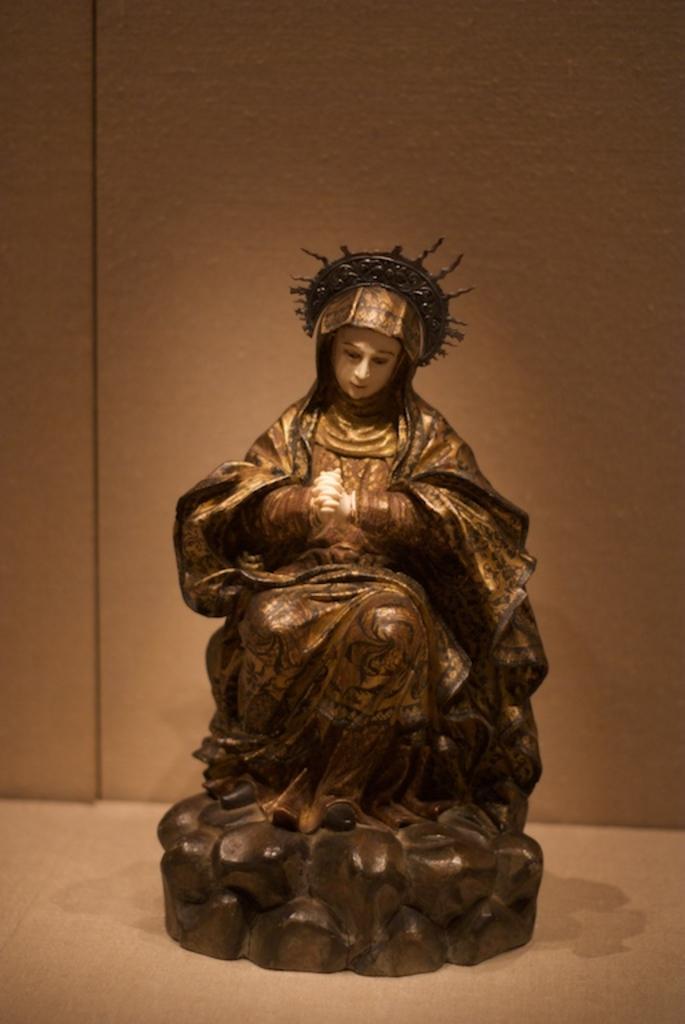Please provide a concise description of this image. In this image I can see a statue of a woman. 